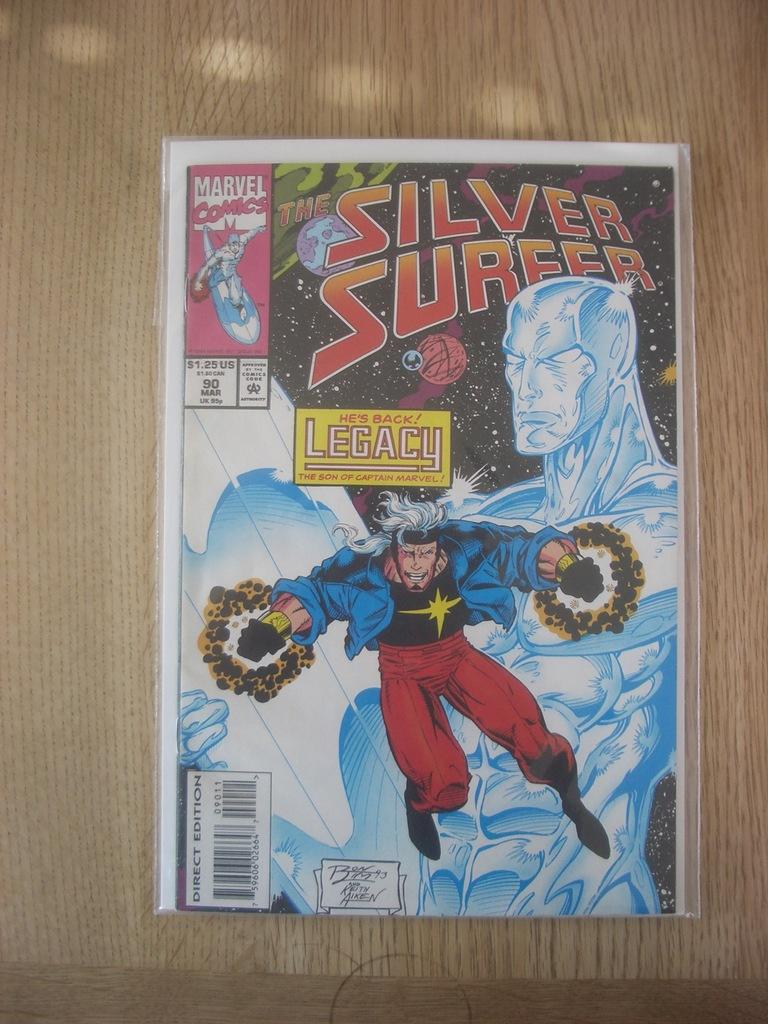What is present on the wooden surface in the image? There is a poster on the wooden surface in the image. What can be seen on the poster? The poster contains images of people and text. How does the bomb explode in the image? There is no bomb present in the image; it only contains a poster with images of people and text. 